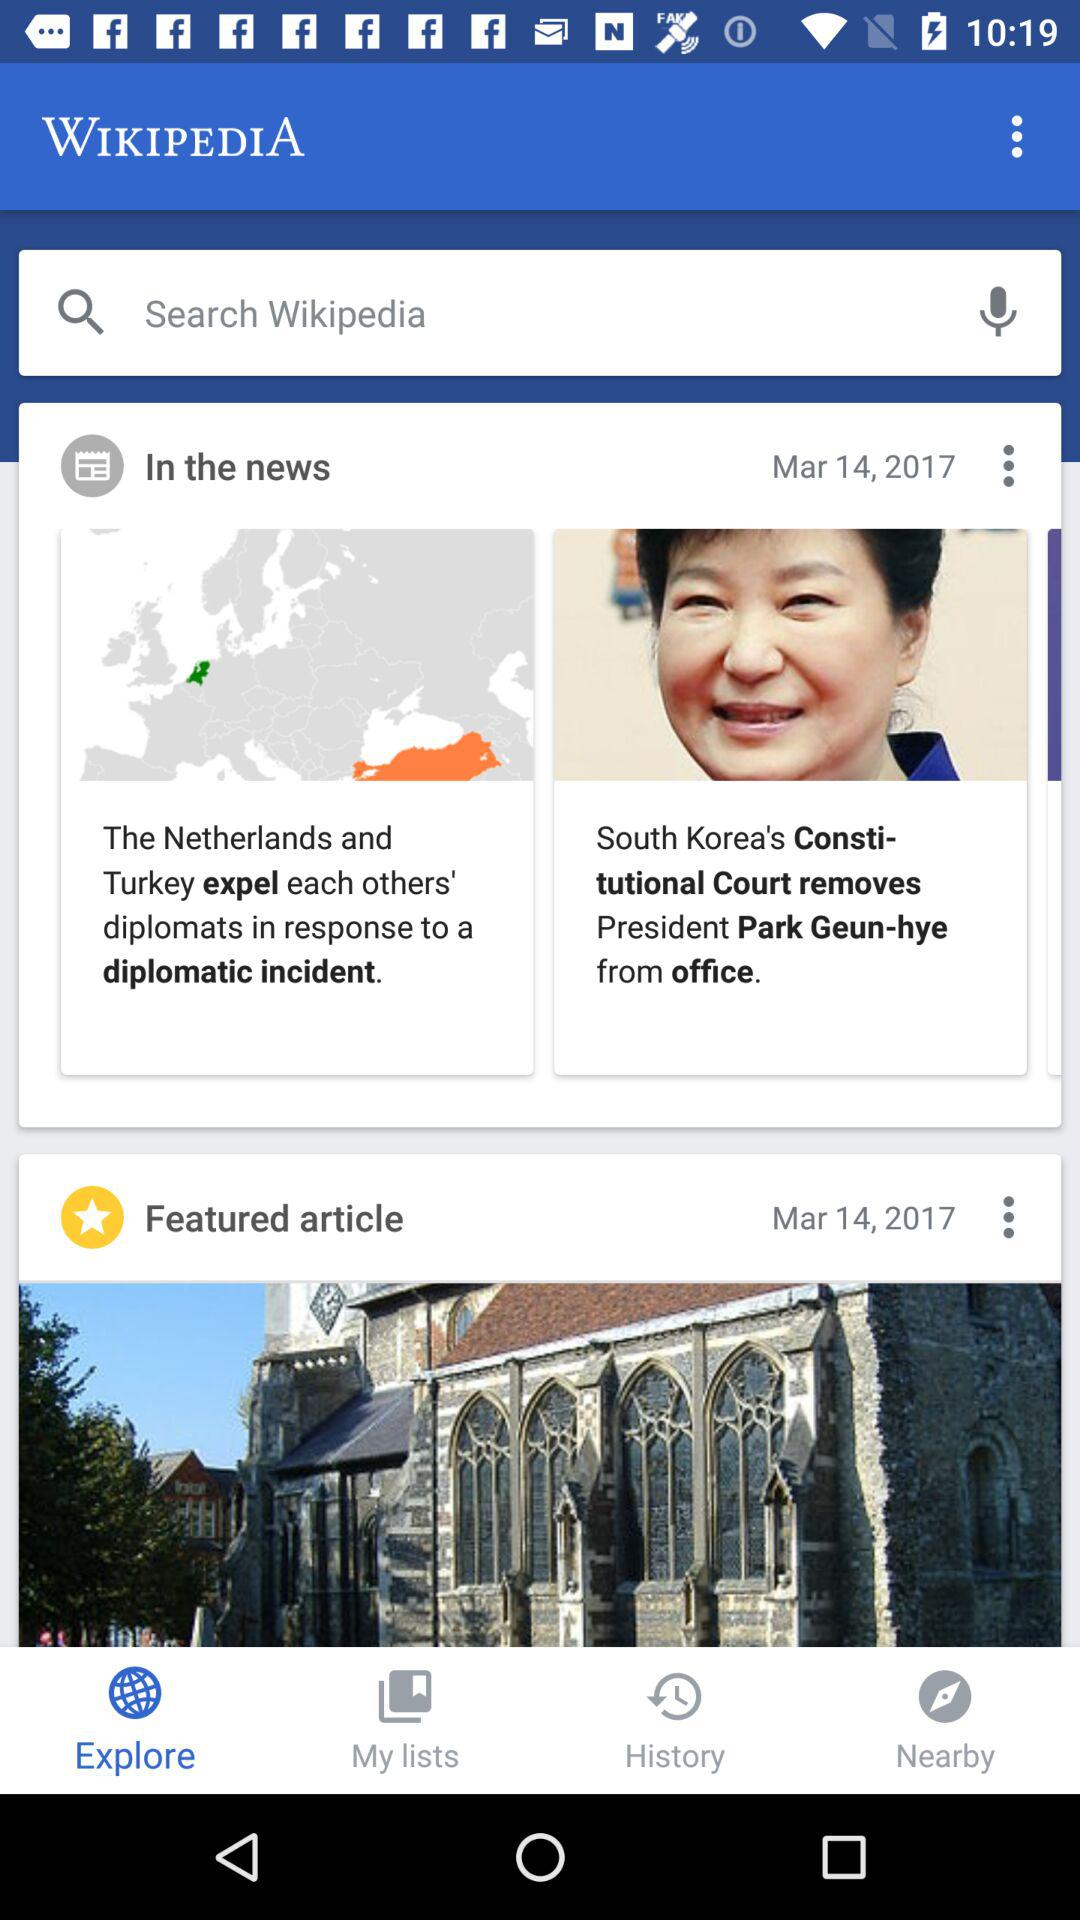When was the featured article published? The featured article was published on March 14, 2017. 